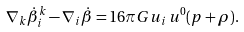Convert formula to latex. <formula><loc_0><loc_0><loc_500><loc_500>\nabla _ { k } \dot { \beta } _ { i } ^ { k } - \nabla _ { i } \dot { \beta } = 1 6 \pi G u _ { i } \, u ^ { 0 } ( p + \rho ) .</formula> 